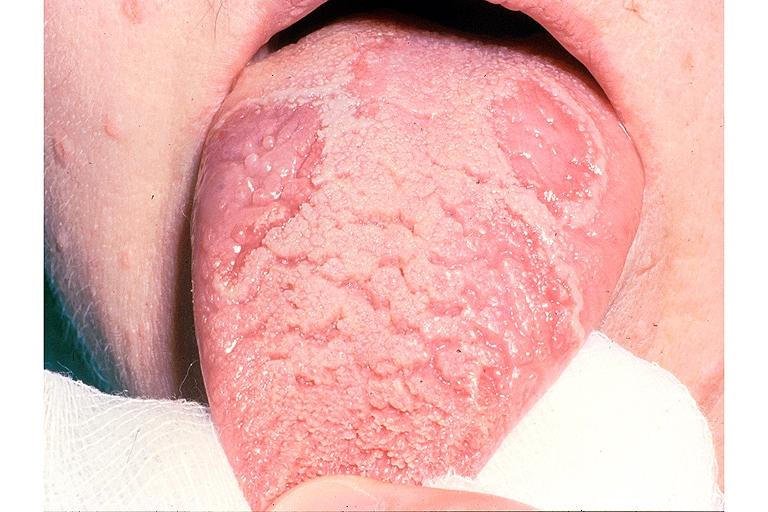what is present?
Answer the question using a single word or phrase. Oral 